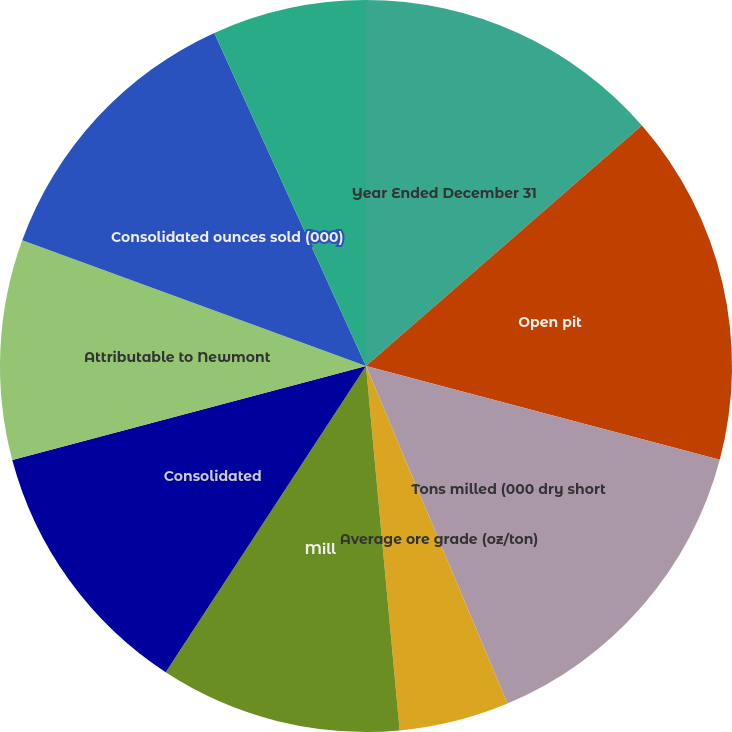Convert chart to OTSL. <chart><loc_0><loc_0><loc_500><loc_500><pie_chart><fcel>Year Ended December 31<fcel>Open pit<fcel>Tons milled (000 dry short<fcel>Average ore grade (oz/ton)<fcel>Average mill recovery rate<fcel>Mill<fcel>Consolidated<fcel>Attributable to Newmont<fcel>Consolidated ounces sold (000)<fcel>Direct mining and production<nl><fcel>13.59%<fcel>15.53%<fcel>14.56%<fcel>0.0%<fcel>4.85%<fcel>10.68%<fcel>11.65%<fcel>9.71%<fcel>12.62%<fcel>6.8%<nl></chart> 